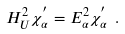<formula> <loc_0><loc_0><loc_500><loc_500>H _ { U } ^ { 2 } \chi _ { \alpha } ^ { ^ { \prime } } = E _ { \alpha } ^ { 2 } \chi _ { \alpha } ^ { ^ { \prime } } \ .</formula> 